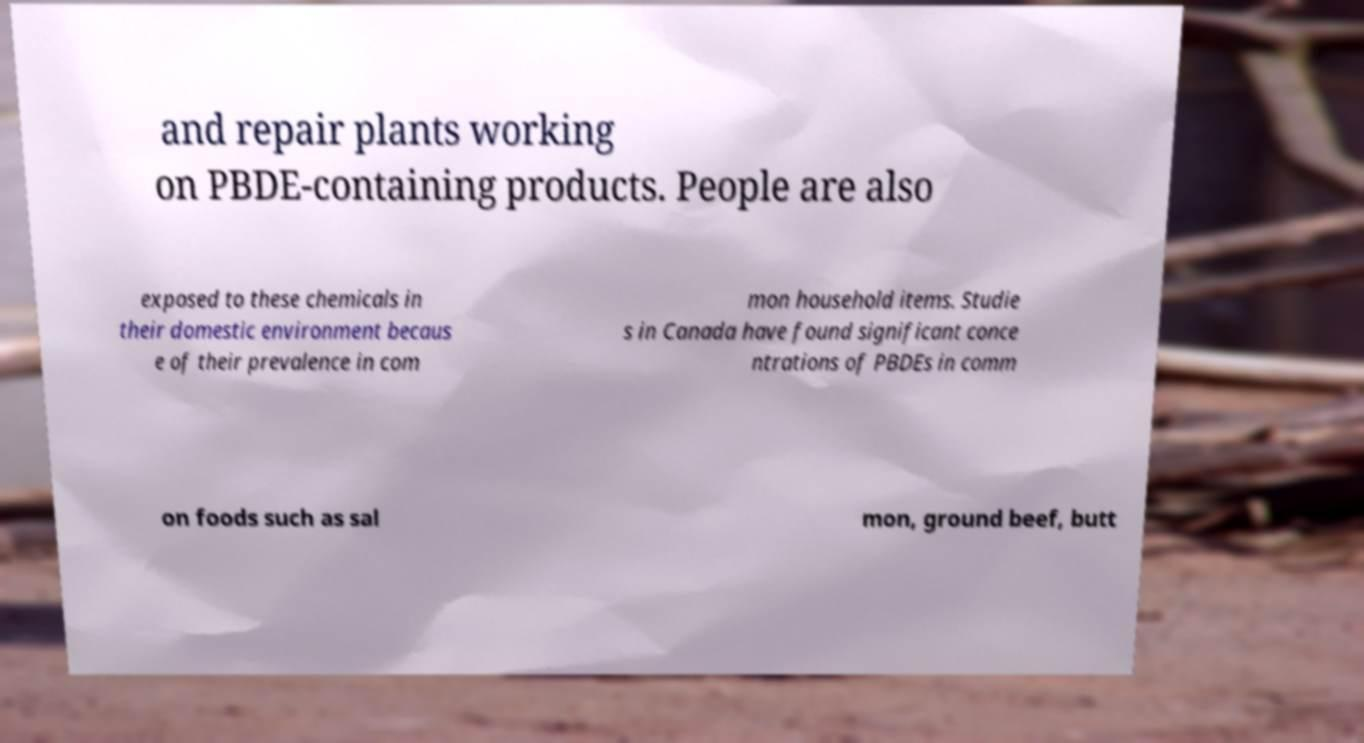What messages or text are displayed in this image? I need them in a readable, typed format. and repair plants working on PBDE-containing products. People are also exposed to these chemicals in their domestic environment becaus e of their prevalence in com mon household items. Studie s in Canada have found significant conce ntrations of PBDEs in comm on foods such as sal mon, ground beef, butt 